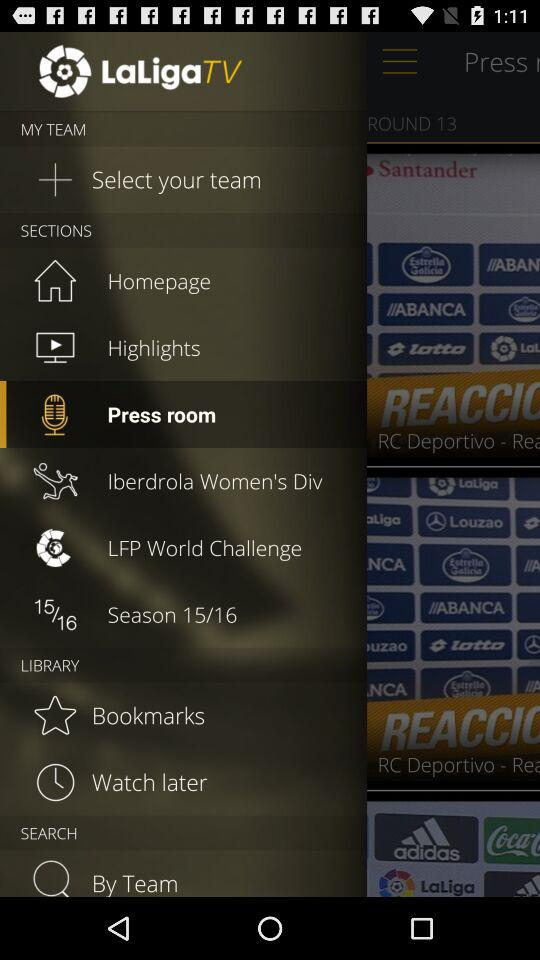What is the mentioned season? The mentioned season is 2015-16. 